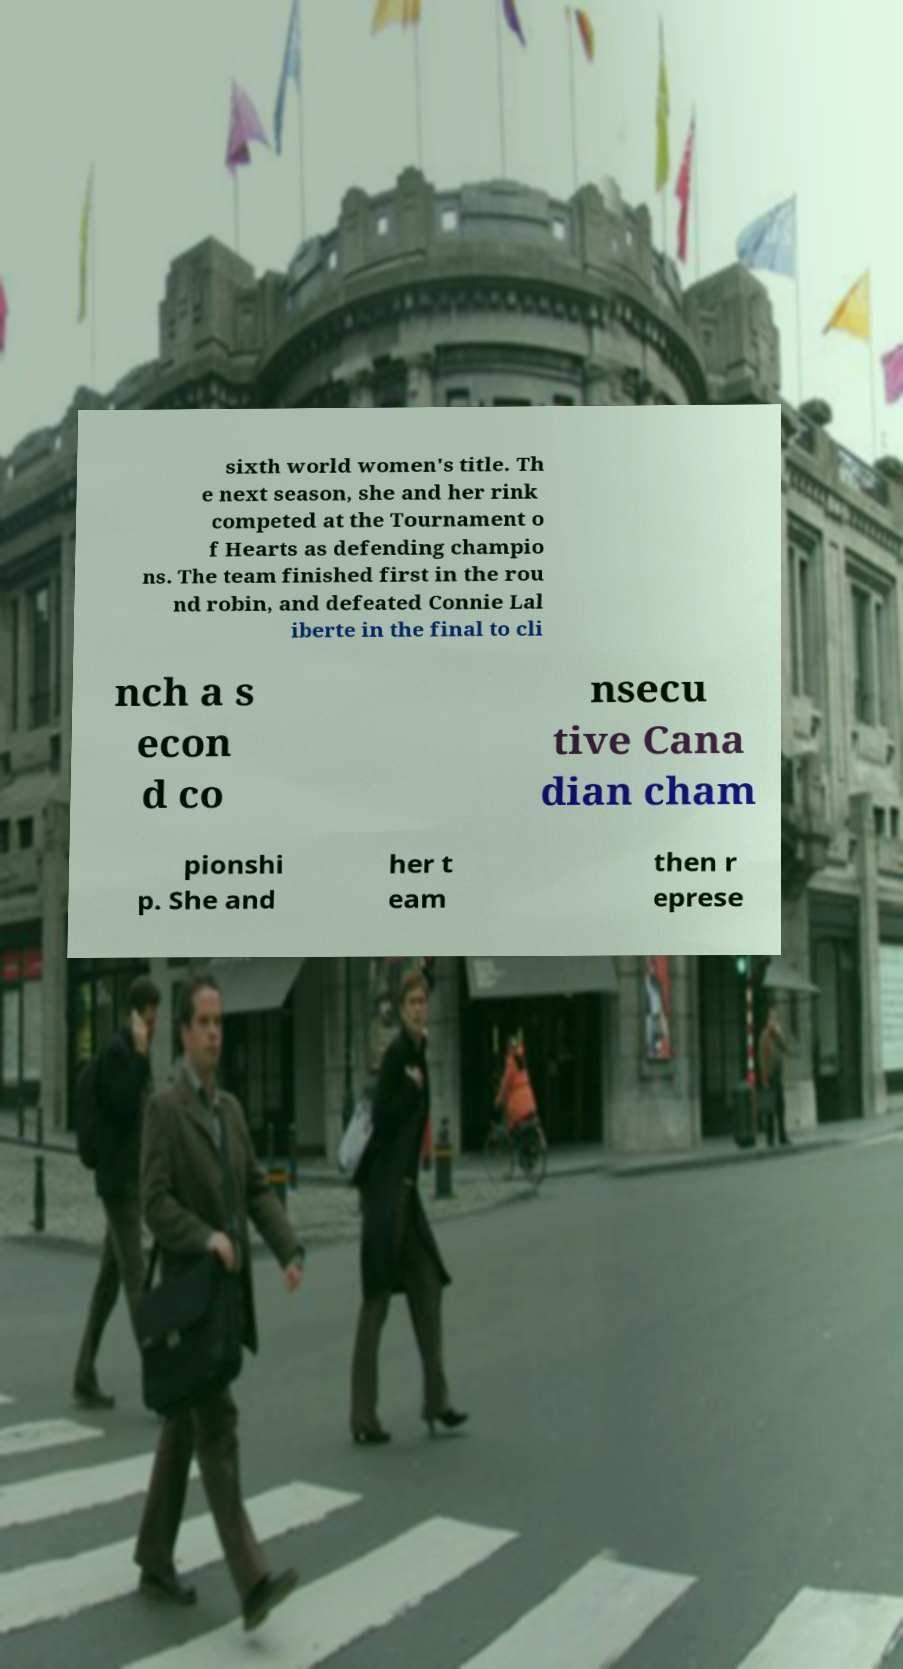I need the written content from this picture converted into text. Can you do that? sixth world women's title. Th e next season, she and her rink competed at the Tournament o f Hearts as defending champio ns. The team finished first in the rou nd robin, and defeated Connie Lal iberte in the final to cli nch a s econ d co nsecu tive Cana dian cham pionshi p. She and her t eam then r eprese 